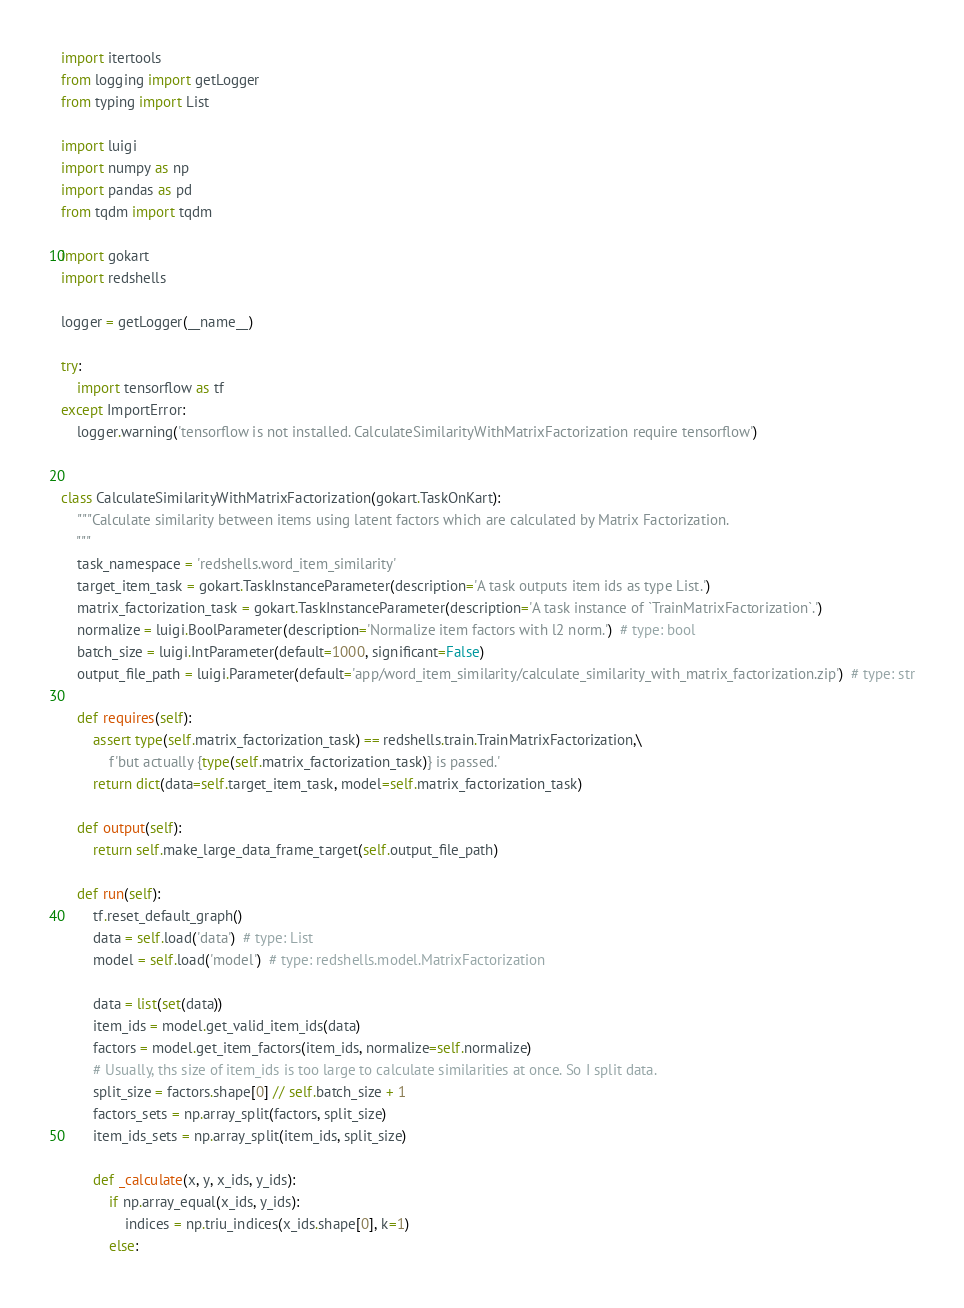Convert code to text. <code><loc_0><loc_0><loc_500><loc_500><_Python_>import itertools
from logging import getLogger
from typing import List

import luigi
import numpy as np
import pandas as pd
from tqdm import tqdm

import gokart
import redshells

logger = getLogger(__name__)

try:
    import tensorflow as tf
except ImportError:
    logger.warning('tensorflow is not installed. CalculateSimilarityWithMatrixFactorization require tensorflow')


class CalculateSimilarityWithMatrixFactorization(gokart.TaskOnKart):
    """Calculate similarity between items using latent factors which are calculated by Matrix Factorization.
    """
    task_namespace = 'redshells.word_item_similarity'
    target_item_task = gokart.TaskInstanceParameter(description='A task outputs item ids as type List.')
    matrix_factorization_task = gokart.TaskInstanceParameter(description='A task instance of `TrainMatrixFactorization`.')
    normalize = luigi.BoolParameter(description='Normalize item factors with l2 norm.')  # type: bool
    batch_size = luigi.IntParameter(default=1000, significant=False)
    output_file_path = luigi.Parameter(default='app/word_item_similarity/calculate_similarity_with_matrix_factorization.zip')  # type: str

    def requires(self):
        assert type(self.matrix_factorization_task) == redshells.train.TrainMatrixFactorization,\
            f'but actually {type(self.matrix_factorization_task)} is passed.'
        return dict(data=self.target_item_task, model=self.matrix_factorization_task)

    def output(self):
        return self.make_large_data_frame_target(self.output_file_path)

    def run(self):
        tf.reset_default_graph()
        data = self.load('data')  # type: List
        model = self.load('model')  # type: redshells.model.MatrixFactorization

        data = list(set(data))
        item_ids = model.get_valid_item_ids(data)
        factors = model.get_item_factors(item_ids, normalize=self.normalize)
        # Usually, ths size of item_ids is too large to calculate similarities at once. So I split data.
        split_size = factors.shape[0] // self.batch_size + 1
        factors_sets = np.array_split(factors, split_size)
        item_ids_sets = np.array_split(item_ids, split_size)

        def _calculate(x, y, x_ids, y_ids):
            if np.array_equal(x_ids, y_ids):
                indices = np.triu_indices(x_ids.shape[0], k=1)
            else:</code> 